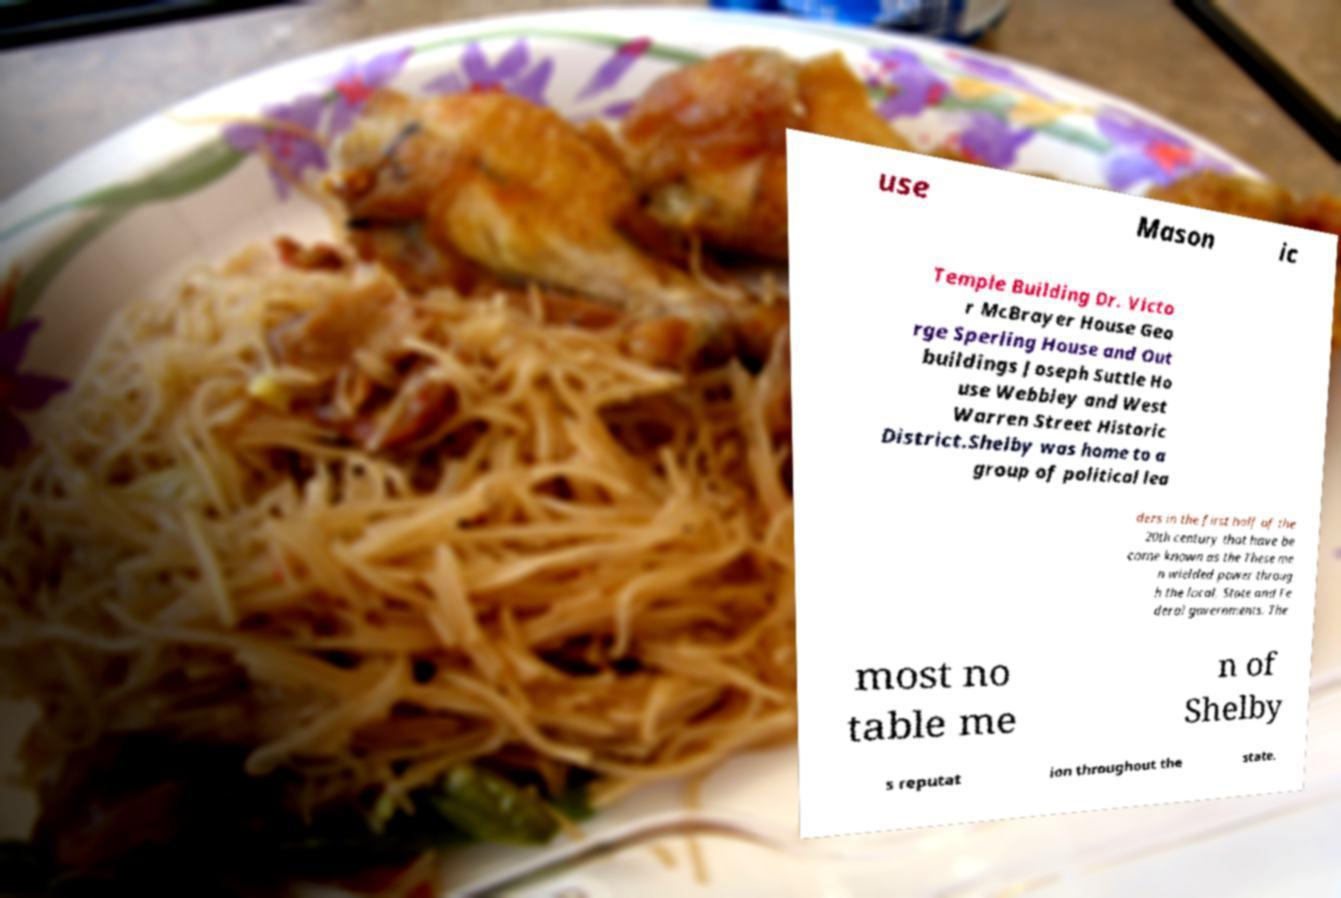Could you extract and type out the text from this image? use Mason ic Temple Building Dr. Victo r McBrayer House Geo rge Sperling House and Out buildings Joseph Suttle Ho use Webbley and West Warren Street Historic District.Shelby was home to a group of political lea ders in the first half of the 20th century that have be come known as the These me n wielded power throug h the local, State and Fe deral governments. The most no table me n of Shelby s reputat ion throughout the state. 